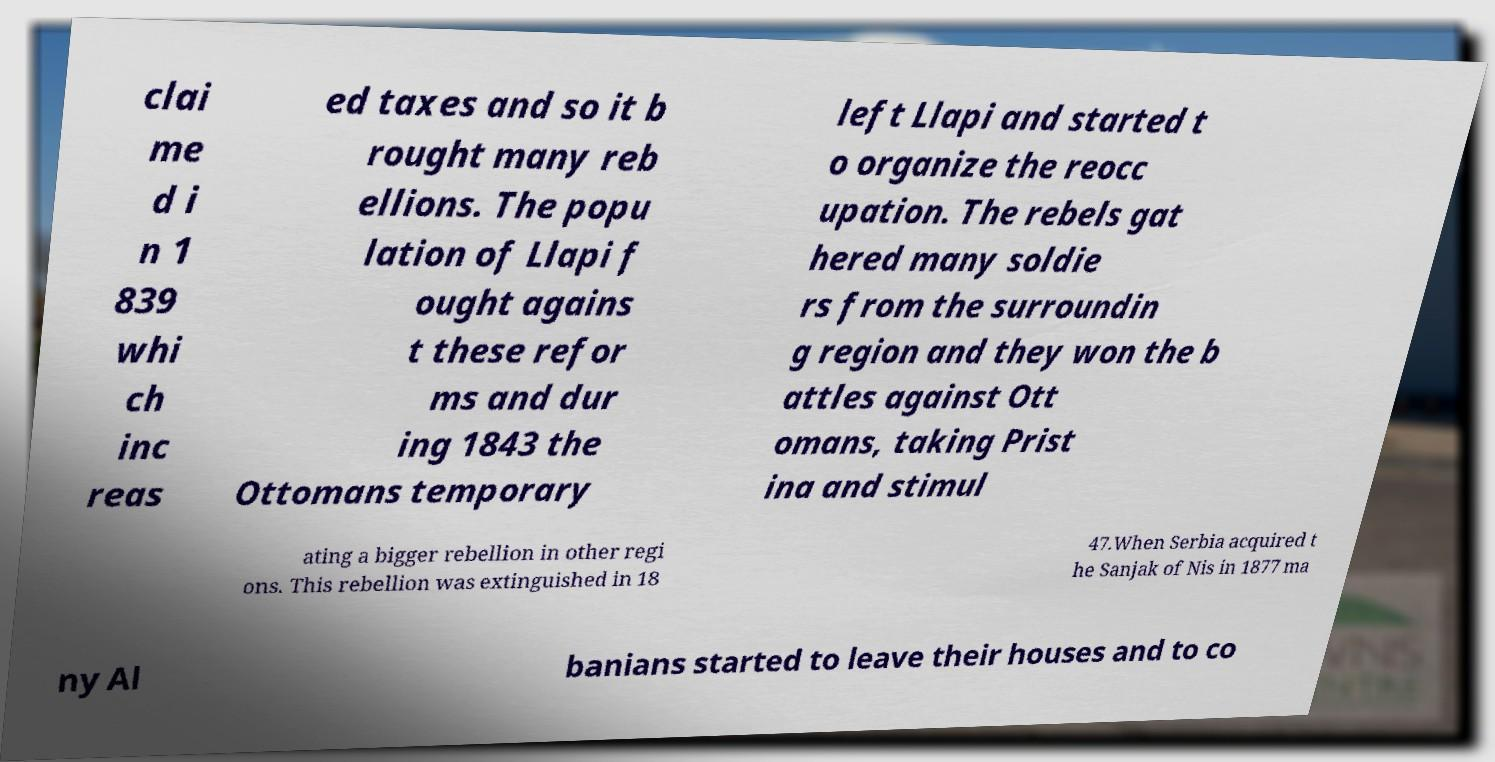What messages or text are displayed in this image? I need them in a readable, typed format. clai me d i n 1 839 whi ch inc reas ed taxes and so it b rought many reb ellions. The popu lation of Llapi f ought agains t these refor ms and dur ing 1843 the Ottomans temporary left Llapi and started t o organize the reocc upation. The rebels gat hered many soldie rs from the surroundin g region and they won the b attles against Ott omans, taking Prist ina and stimul ating a bigger rebellion in other regi ons. This rebellion was extinguished in 18 47.When Serbia acquired t he Sanjak of Nis in 1877 ma ny Al banians started to leave their houses and to co 